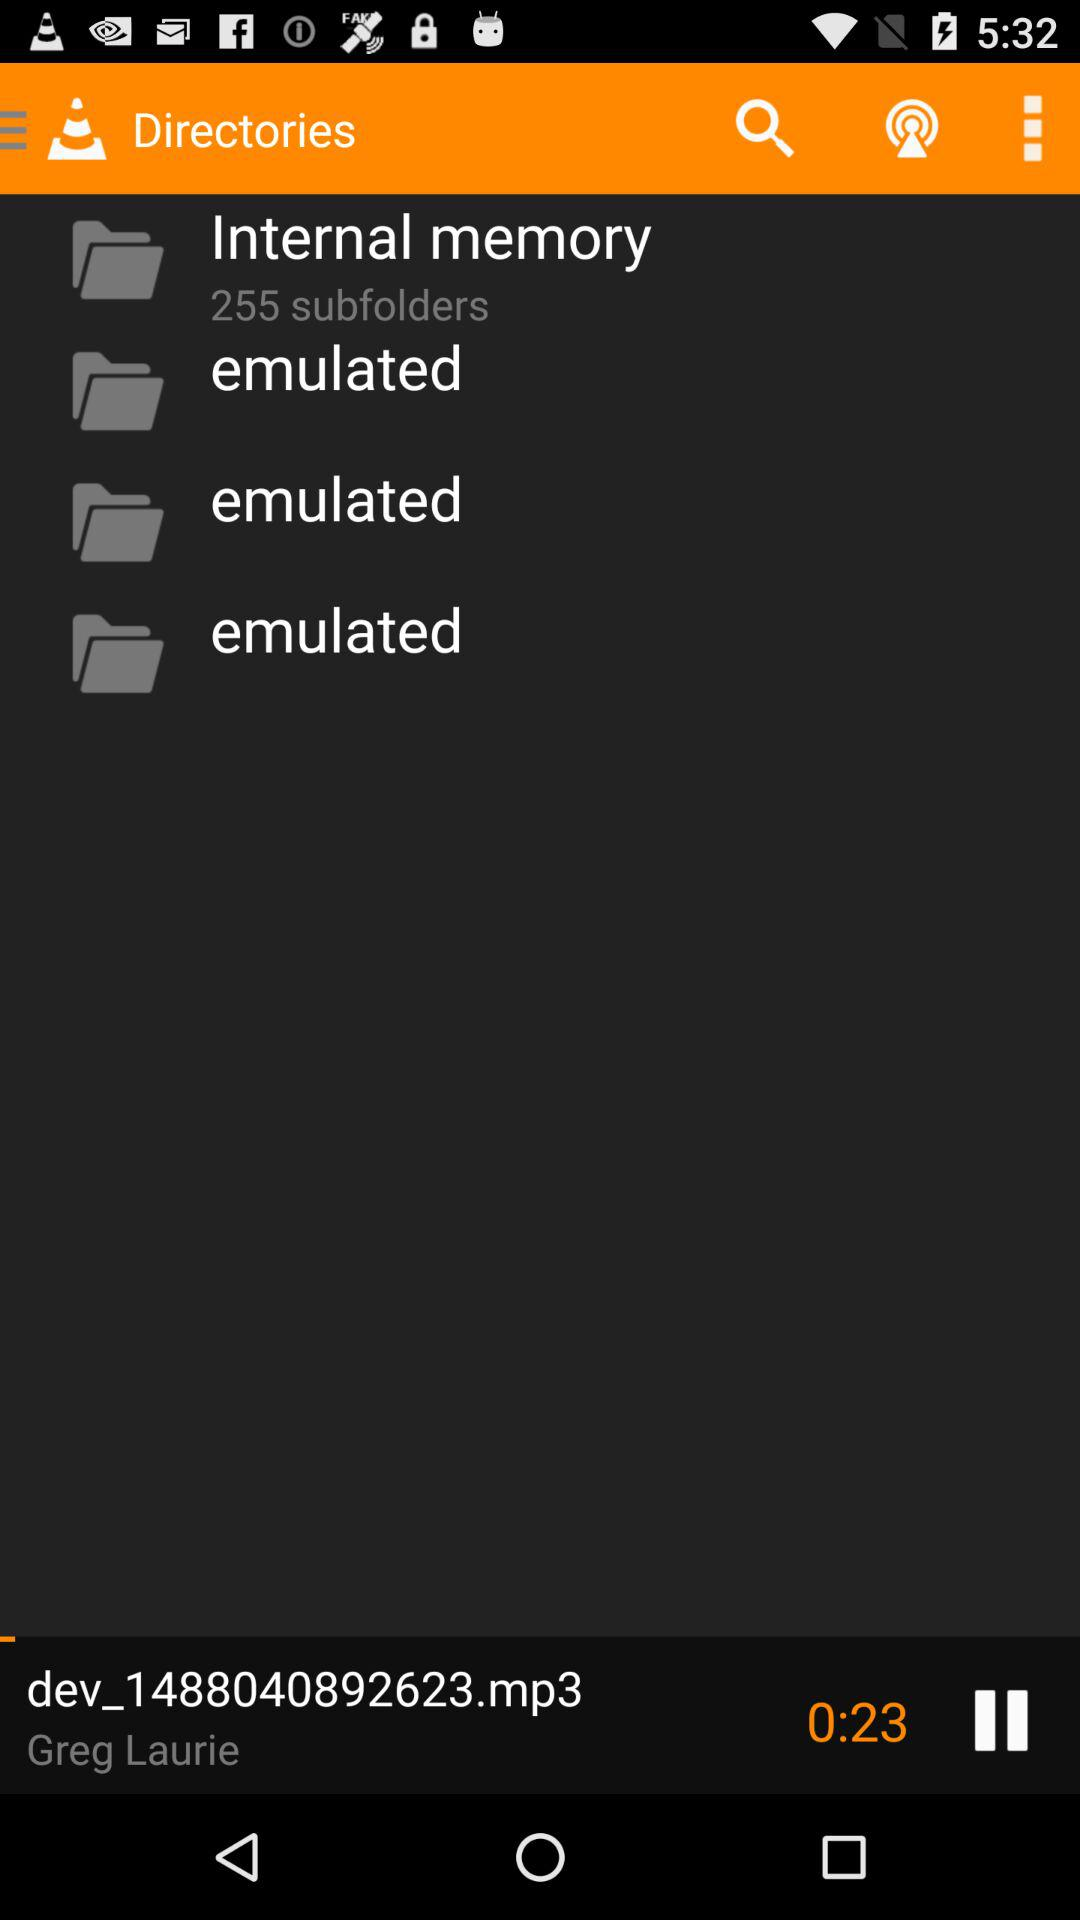How many subfolders are in "Internal memory"? There are 255 subfolders. 